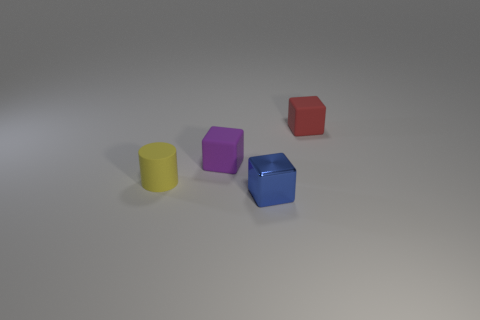The tiny yellow object that is made of the same material as the red cube is what shape? cylinder 